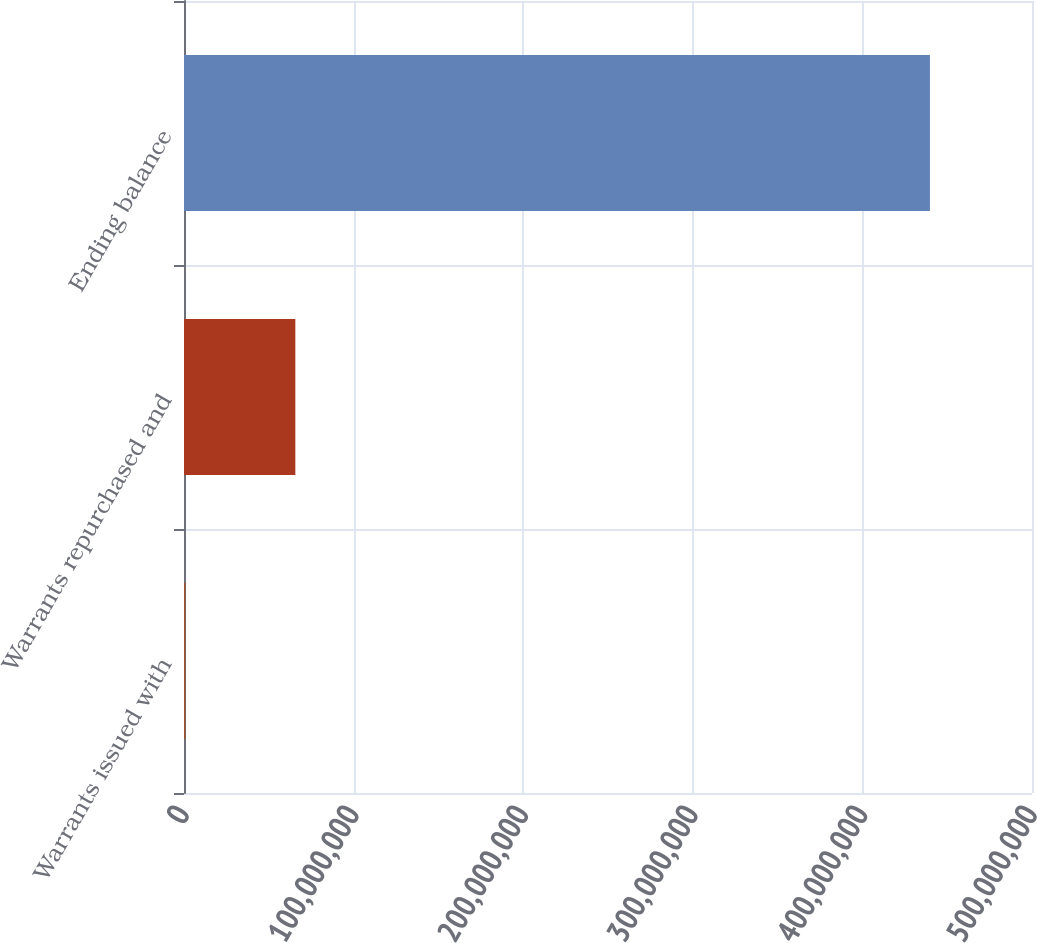Convert chart to OTSL. <chart><loc_0><loc_0><loc_500><loc_500><bar_chart><fcel>Warrants issued with<fcel>Warrants repurchased and<fcel>Ending balance<nl><fcel>859796<fcel>6.56492e+07<fcel>4.39809e+08<nl></chart> 